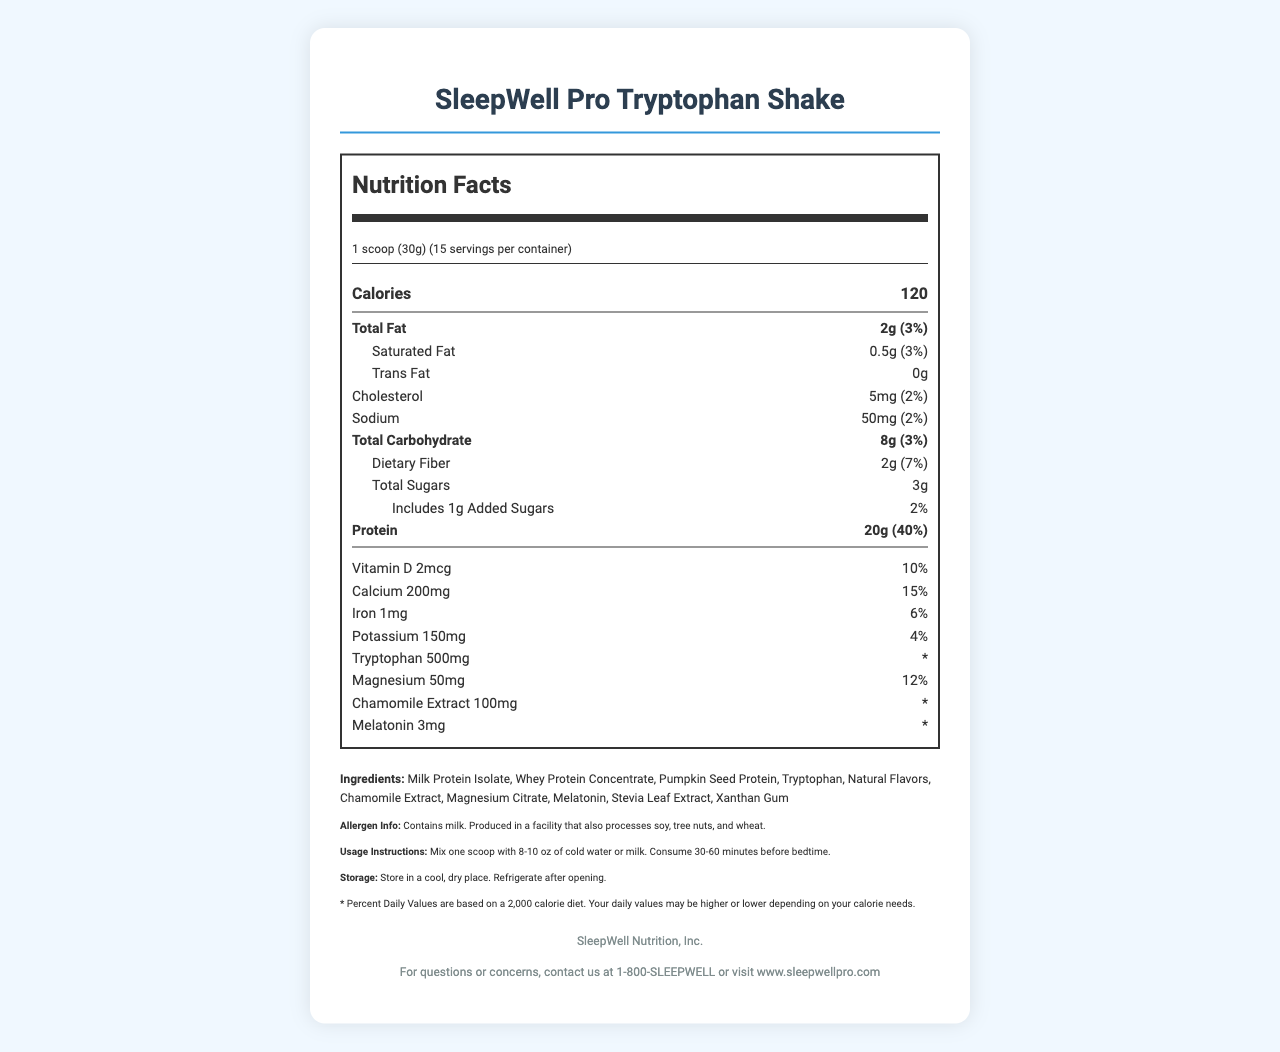what is the product name? The product name is displayed at the top of the document and in the title.
Answer: SleepWell Pro Tryptophan Shake how many calories are in one serving? The calories per serving are listed as 120 in the nutrients section.
Answer: 120 how much protein is in one serving? The amount of protein per serving is provided as 20g in the nutrients section.
Answer: 20g what is the daily value percentage for calcium? The daily value percentage for calcium is listed as 15% in the vitamins section.
Answer: 15% how much melatonin does each serving contain? The amount of melatonin per serving is indicated as 3mg in the vitamins section.
Answer: 3mg which allergens are present in this product? A. Soy B. Wheat C. Milk D. All of the above The allergen information states that the product contains milk.
Answer: C. Milk what is the recommended time to consume this shake? A. Morning B. Afternoon C. 30-60 minutes before bedtime D. After a workout The usage instructions state to consume the shake 30-60 minutes before bedtime.
Answer: C. 30-60 minutes before bedtime how much dietary fiber is in one serving? The dietary fiber content per serving is listed as 2g in the nutrients section.
Answer: 2g does this product contain any added sugars? The document shows the product includes 1g of added sugars.
Answer: Yes what is the main idea of this document? The document gives detailed information on serving size, nutritional contents, ingredients, allergens, usage instructions, storage information, and manufacturer details.
Answer: The document provides the nutrition facts and other relevant information for the "SleepWell Pro Tryptophan Shake," a night-time protein shake. are there any vitamins listed in the document? Vitamin D, calcium, iron, and potassium are listed in the vitamins section.
Answer: Yes what is the amount of tryptophan in one serving? The amount of tryptophan per serving is specified as 500mg in the vitamins section.
Answer: 500mg which ingredient is not listed in the document? A. Milk Protein Isolate B. Stevia Leaf Extract C. Soy Protein Isolate D. Xanthan Gum Soy Protein Isolate is not listed among the ingredients.
Answer: C. Soy Protein Isolate how many servings are there in the container? The document specifies that there are 15 servings per container.
Answer: 15 what is the daily value percentage for magnesium? The daily value percentage for magnesium is listed as 12%.
Answer: 12% how much sodium does each serving of this shake contain? The amount of sodium per serving is indicated as 50mg in the nutrients section.
Answer: 50mg what is the flavor of this shake? The document does not mention the flavor of the shake.
Answer: Not enough information 